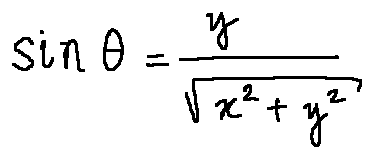<formula> <loc_0><loc_0><loc_500><loc_500>\sin \theta = \frac { y } { \sqrt { x ^ { 2 } + y ^ { 2 } } }</formula> 